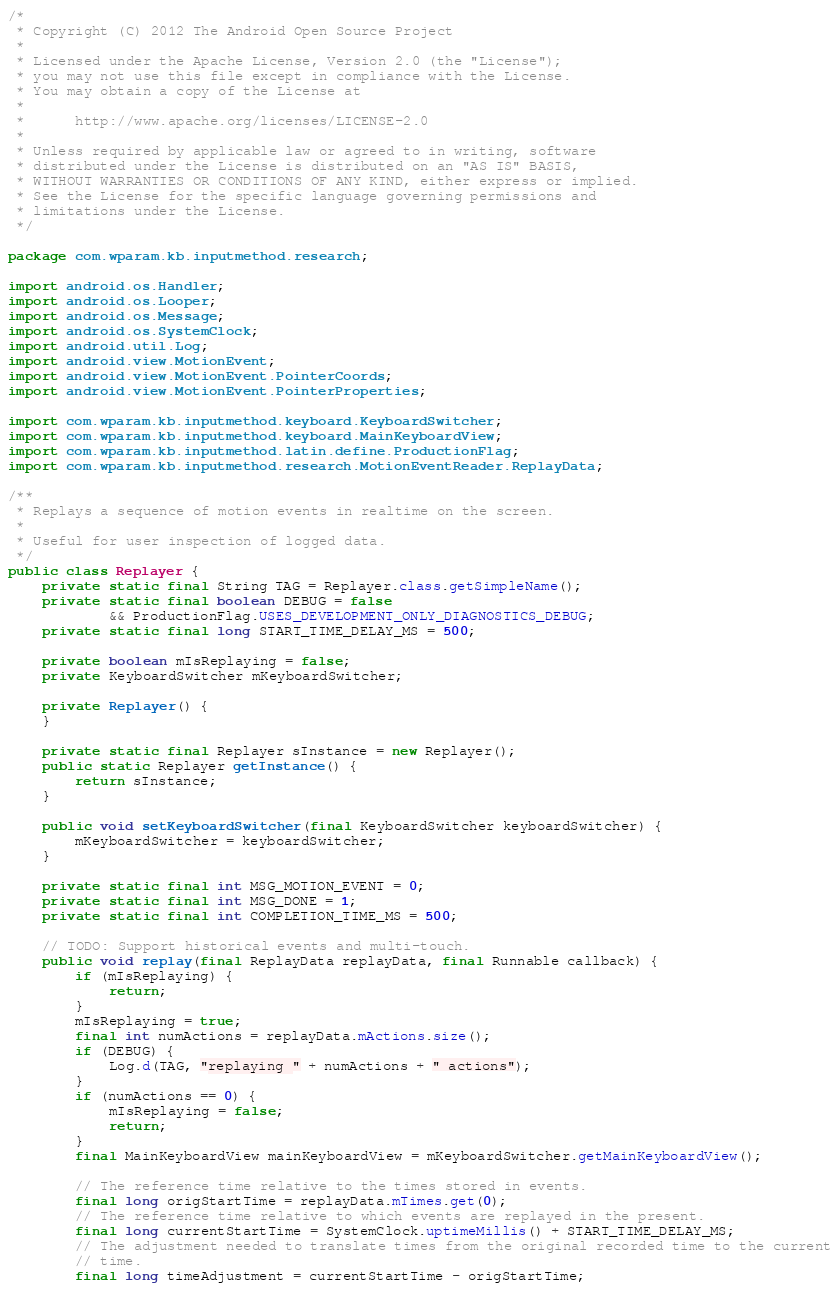<code> <loc_0><loc_0><loc_500><loc_500><_Java_>/*
 * Copyright (C) 2012 The Android Open Source Project
 *
 * Licensed under the Apache License, Version 2.0 (the "License");
 * you may not use this file except in compliance with the License.
 * You may obtain a copy of the License at
 *
 *      http://www.apache.org/licenses/LICENSE-2.0
 *
 * Unless required by applicable law or agreed to in writing, software
 * distributed under the License is distributed on an "AS IS" BASIS,
 * WITHOUT WARRANTIES OR CONDITIONS OF ANY KIND, either express or implied.
 * See the License for the specific language governing permissions and
 * limitations under the License.
 */

package com.wparam.kb.inputmethod.research;

import android.os.Handler;
import android.os.Looper;
import android.os.Message;
import android.os.SystemClock;
import android.util.Log;
import android.view.MotionEvent;
import android.view.MotionEvent.PointerCoords;
import android.view.MotionEvent.PointerProperties;

import com.wparam.kb.inputmethod.keyboard.KeyboardSwitcher;
import com.wparam.kb.inputmethod.keyboard.MainKeyboardView;
import com.wparam.kb.inputmethod.latin.define.ProductionFlag;
import com.wparam.kb.inputmethod.research.MotionEventReader.ReplayData;

/**
 * Replays a sequence of motion events in realtime on the screen.
 *
 * Useful for user inspection of logged data.
 */
public class Replayer {
    private static final String TAG = Replayer.class.getSimpleName();
    private static final boolean DEBUG = false
            && ProductionFlag.USES_DEVELOPMENT_ONLY_DIAGNOSTICS_DEBUG;
    private static final long START_TIME_DELAY_MS = 500;

    private boolean mIsReplaying = false;
    private KeyboardSwitcher mKeyboardSwitcher;

    private Replayer() {
    }

    private static final Replayer sInstance = new Replayer();
    public static Replayer getInstance() {
        return sInstance;
    }

    public void setKeyboardSwitcher(final KeyboardSwitcher keyboardSwitcher) {
        mKeyboardSwitcher = keyboardSwitcher;
    }

    private static final int MSG_MOTION_EVENT = 0;
    private static final int MSG_DONE = 1;
    private static final int COMPLETION_TIME_MS = 500;

    // TODO: Support historical events and multi-touch.
    public void replay(final ReplayData replayData, final Runnable callback) {
        if (mIsReplaying) {
            return;
        }
        mIsReplaying = true;
        final int numActions = replayData.mActions.size();
        if (DEBUG) {
            Log.d(TAG, "replaying " + numActions + " actions");
        }
        if (numActions == 0) {
            mIsReplaying = false;
            return;
        }
        final MainKeyboardView mainKeyboardView = mKeyboardSwitcher.getMainKeyboardView();

        // The reference time relative to the times stored in events.
        final long origStartTime = replayData.mTimes.get(0);
        // The reference time relative to which events are replayed in the present.
        final long currentStartTime = SystemClock.uptimeMillis() + START_TIME_DELAY_MS;
        // The adjustment needed to translate times from the original recorded time to the current
        // time.
        final long timeAdjustment = currentStartTime - origStartTime;</code> 